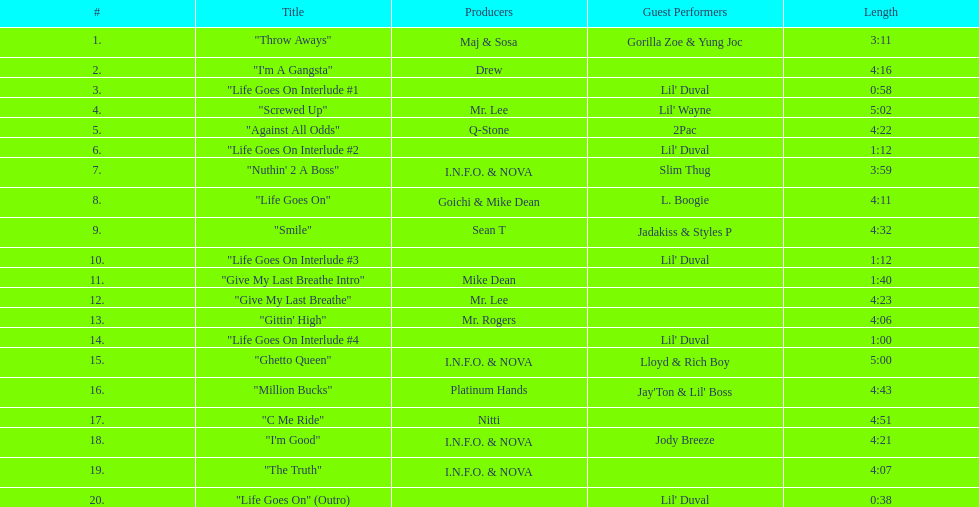What is the last track produced by mr. lee? "Give My Last Breathe". 